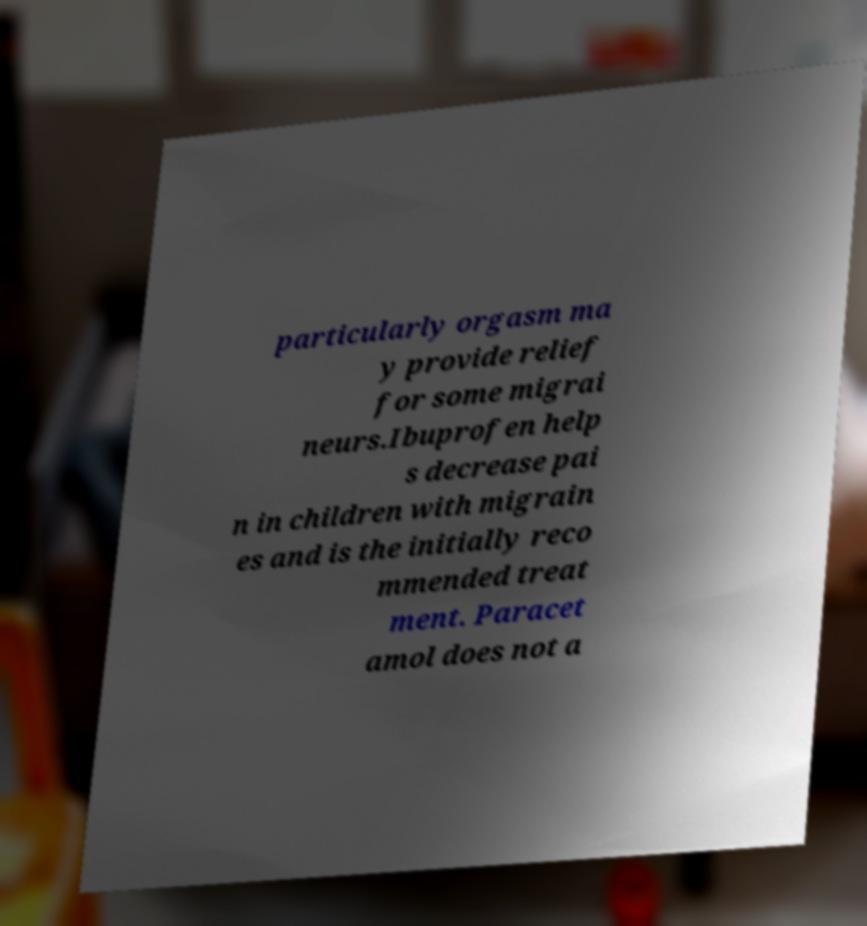For documentation purposes, I need the text within this image transcribed. Could you provide that? particularly orgasm ma y provide relief for some migrai neurs.Ibuprofen help s decrease pai n in children with migrain es and is the initially reco mmended treat ment. Paracet amol does not a 